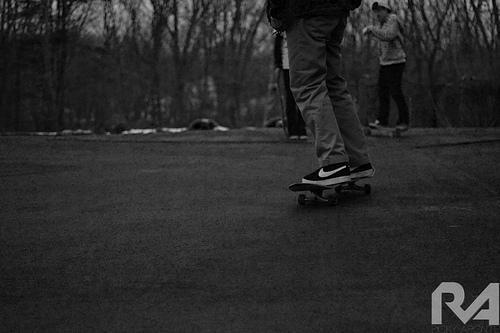How many people are pictured?
Give a very brief answer. 3. 